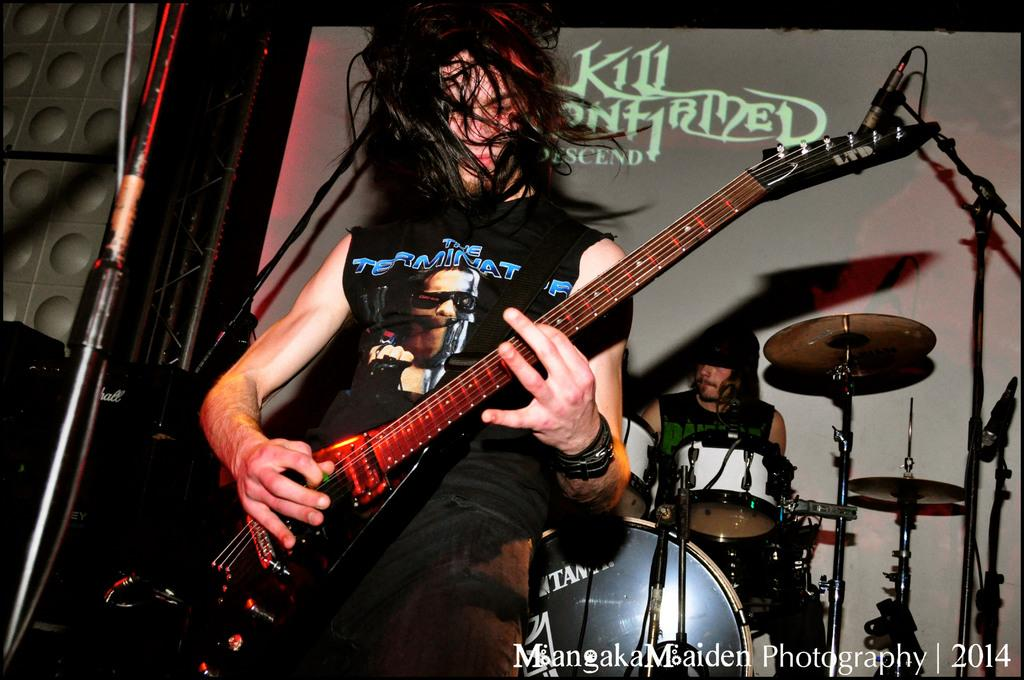What is the main subject of the image? There is a person playing in the image. Can you describe the activity of the person in the image? The person is playing, but the specific activity is not mentioned. Are there any other people or activities visible in the image? Yes, there is another person playing drums in the background of the image. What type of popcorn is being served in the office during the work meeting in the image? There is no mention of popcorn, work, or an office in the image. The image only shows a person playing and another person playing drums in the background. 